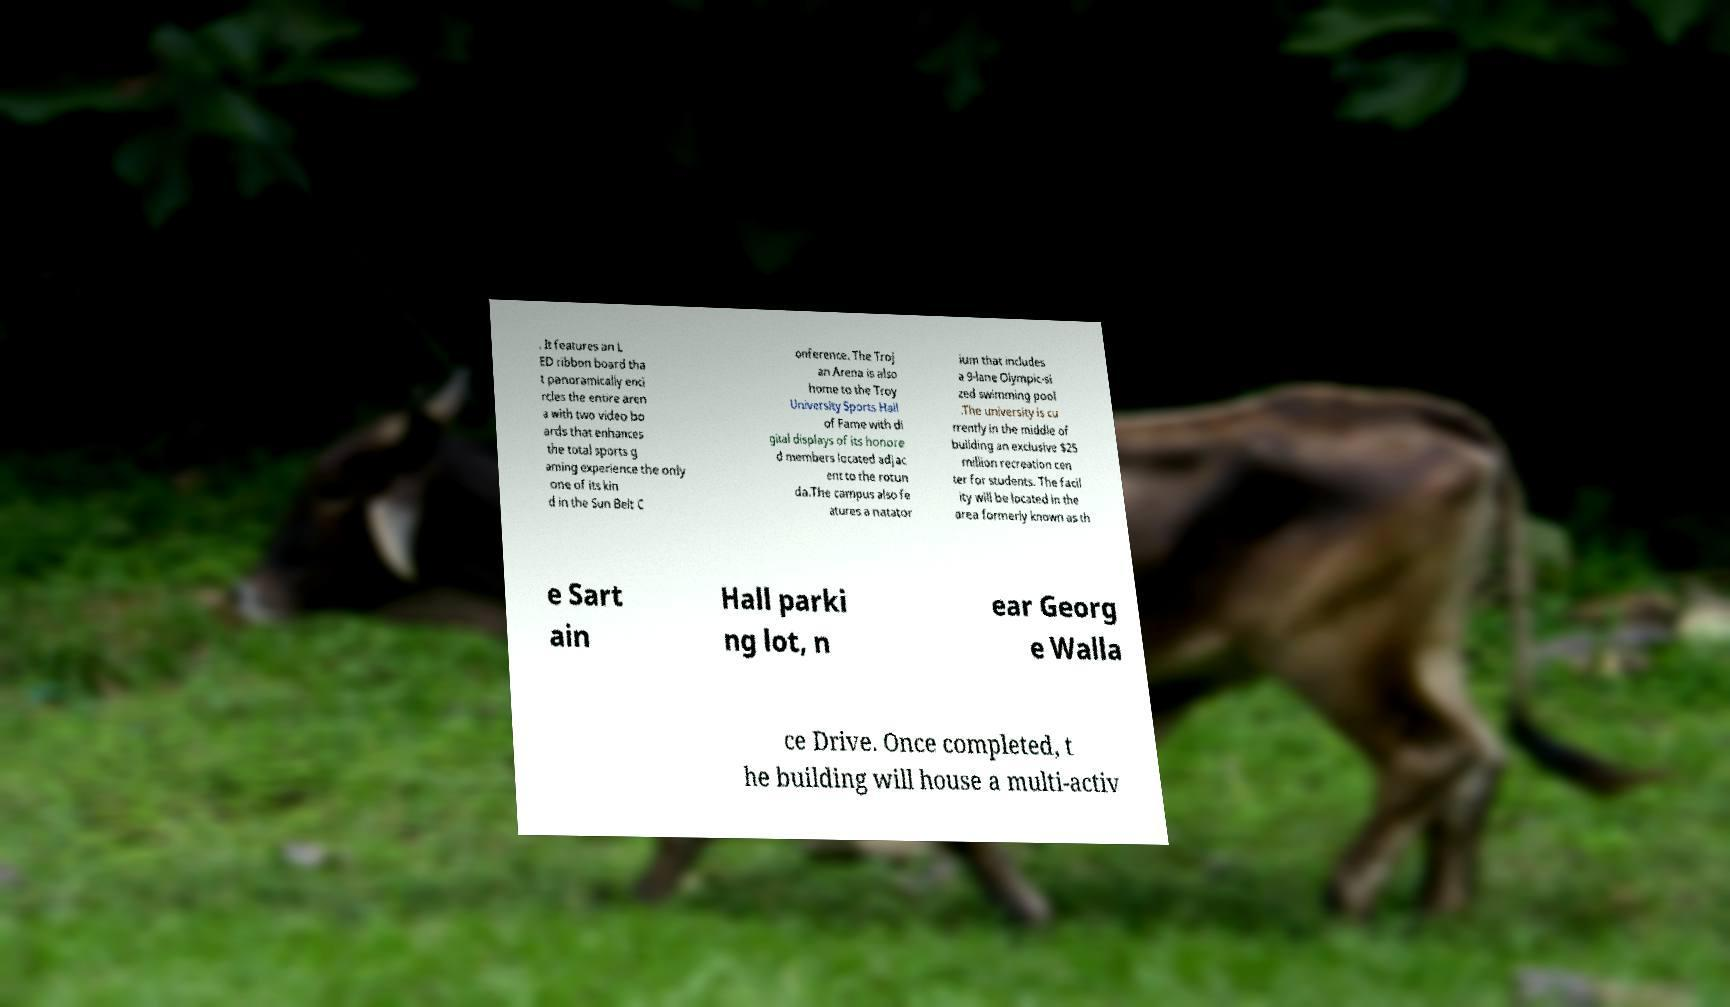Could you assist in decoding the text presented in this image and type it out clearly? . It features an L ED ribbon board tha t panoramically enci rcles the entire aren a with two video bo ards that enhances the total sports g aming experience the only one of its kin d in the Sun Belt C onference. The Troj an Arena is also home to the Troy University Sports Hall of Fame with di gital displays of its honore d members located adjac ent to the rotun da.The campus also fe atures a natator ium that includes a 9-lane Olympic-si zed swimming pool .The university is cu rrently in the middle of building an exclusive $25 million recreation cen ter for students. The facil ity will be located in the area formerly known as th e Sart ain Hall parki ng lot, n ear Georg e Walla ce Drive. Once completed, t he building will house a multi-activ 